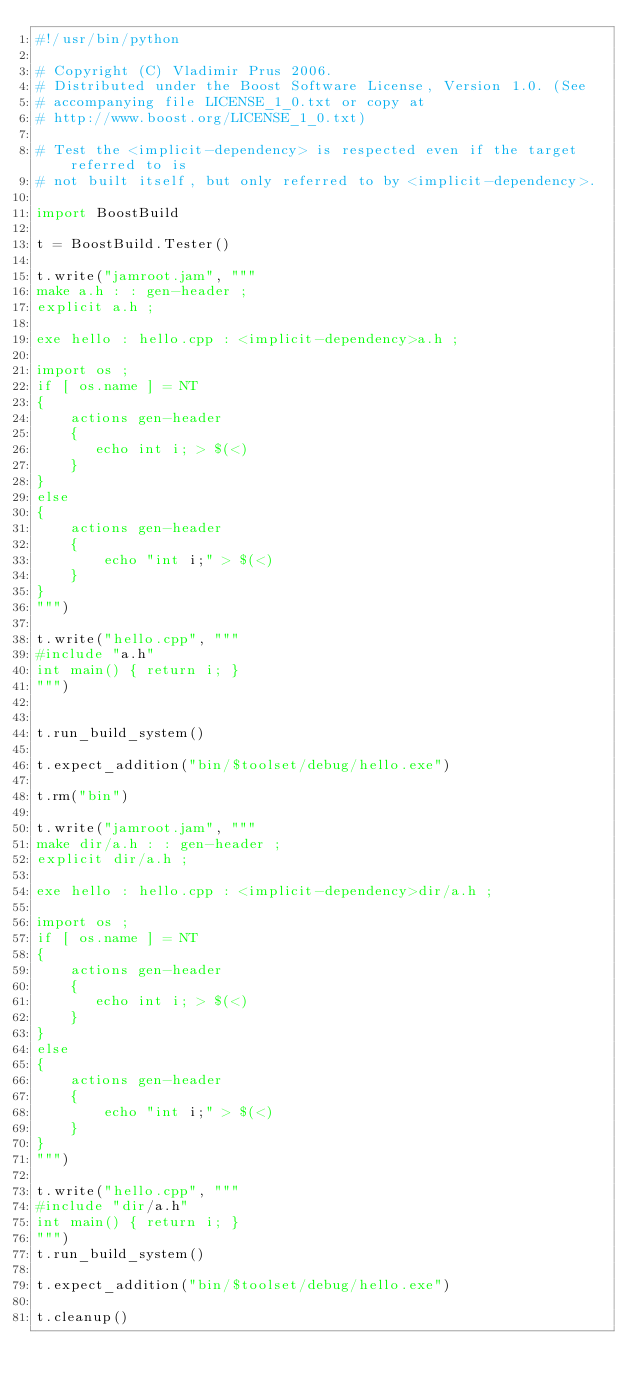Convert code to text. <code><loc_0><loc_0><loc_500><loc_500><_Python_>#!/usr/bin/python

# Copyright (C) Vladimir Prus 2006.
# Distributed under the Boost Software License, Version 1.0. (See
# accompanying file LICENSE_1_0.txt or copy at
# http://www.boost.org/LICENSE_1_0.txt)

# Test the <implicit-dependency> is respected even if the target referred to is
# not built itself, but only referred to by <implicit-dependency>.

import BoostBuild

t = BoostBuild.Tester()

t.write("jamroot.jam", """
make a.h : : gen-header ;
explicit a.h ;

exe hello : hello.cpp : <implicit-dependency>a.h ;

import os ;
if [ os.name ] = NT
{
    actions gen-header
    {
       echo int i; > $(<)
    }
}
else
{
    actions gen-header
    {
        echo "int i;" > $(<)
    }
}
""")

t.write("hello.cpp", """
#include "a.h"
int main() { return i; }
""")


t.run_build_system()

t.expect_addition("bin/$toolset/debug/hello.exe")

t.rm("bin")

t.write("jamroot.jam", """
make dir/a.h : : gen-header ;
explicit dir/a.h ;

exe hello : hello.cpp : <implicit-dependency>dir/a.h ;

import os ;
if [ os.name ] = NT
{
    actions gen-header
    {
       echo int i; > $(<)
    }
}
else
{
    actions gen-header
    {
        echo "int i;" > $(<)
    }
}
""")

t.write("hello.cpp", """
#include "dir/a.h"
int main() { return i; }
""")
t.run_build_system()

t.expect_addition("bin/$toolset/debug/hello.exe")

t.cleanup()
</code> 